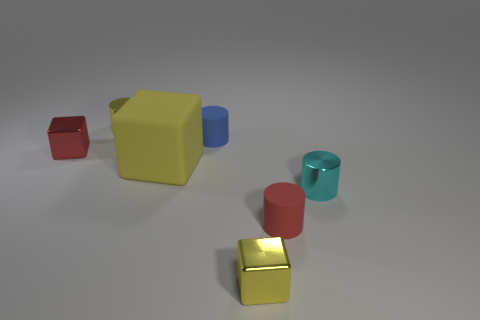Is the tiny cyan object the same shape as the blue matte object?
Your response must be concise. Yes. What number of objects are either small yellow shiny objects behind the tiny red shiny thing or yellow objects in front of the small cyan cylinder?
Offer a very short reply. 2. How many things are yellow metal cylinders or cylinders?
Your answer should be very brief. 4. There is a tiny matte object on the left side of the red cylinder; how many red shiny blocks are in front of it?
Your response must be concise. 1. What number of other objects are there of the same size as the red matte object?
Your answer should be very brief. 5. Does the tiny shiny thing right of the red rubber cylinder have the same shape as the small blue thing?
Your answer should be compact. Yes. What material is the yellow cube behind the tiny red cylinder?
Give a very brief answer. Rubber. Is there another small cyan object that has the same material as the small cyan object?
Offer a terse response. No. The yellow shiny cube is what size?
Your answer should be compact. Small. What number of cyan things are either large matte blocks or metallic things?
Offer a terse response. 1. 